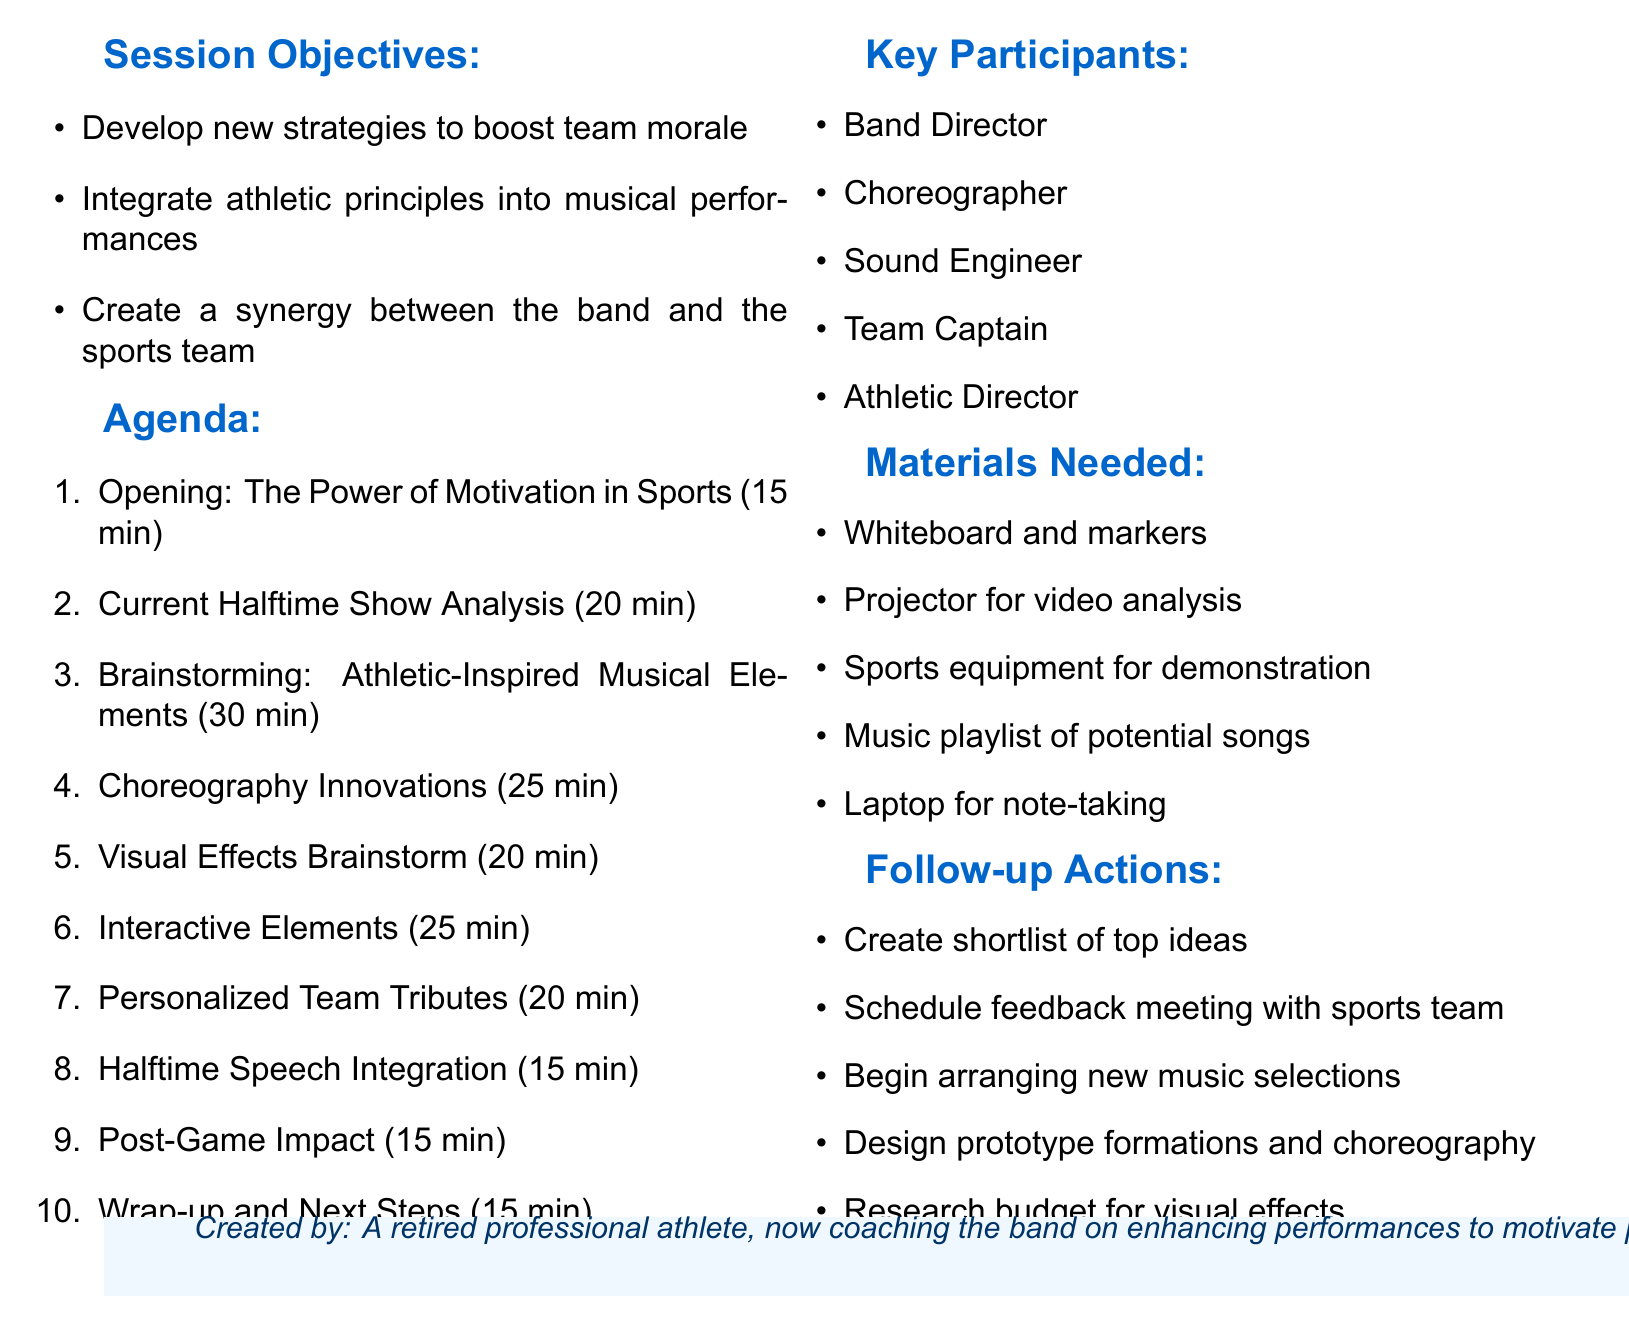What is the title of the session? The title of the session is stated clearly at the top of the document, which is "Enhancing Halftime Shows: Motivational Techniques Brainstorming."
Answer: Enhancing Halftime Shows: Motivational Techniques Brainstorming How many agenda items are listed? The total number of agenda items can be counted from the agenda section of the document, which lists ten items.
Answer: 10 Who are the key participants listed in the document? The key participants can be found in the specific section and include titles such as "Band Director," "Choreographer," and others.
Answer: Band Director, Choreographer, Sound Engineer, Team Captain, Athletic Director What is the duration of the "Choreography Innovations" item? The duration of this specific agenda item is mentioned in the agenda, which is 25 minutes.
Answer: 25 minutes What is one of the session objectives? One of the session objectives is found in the objectives section and is meant to enhance team morale through halftime performances.
Answer: Develop new strategies to boost team morale through halftime performances What materials are needed for the session? The materials required for the session are listed, such as "Whiteboard and markers" and "Projector for video analysis."
Answer: Whiteboard and markers, Projector for video analysis How long is the "Current Halftime Show Analysis" segment? The time allocated for this segment is provided in the agenda section and is 20 minutes long.
Answer: 20 minutes What is the action item regarding new music selections? This action item can be found in the follow-up actions section, indicating plans to arrange music selections for the band.
Answer: Begin arranging new music selections for the band 